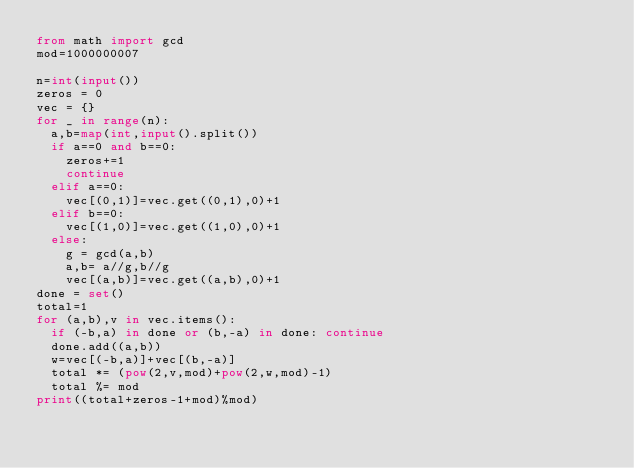<code> <loc_0><loc_0><loc_500><loc_500><_Python_>from math import gcd
mod=1000000007

n=int(input())
zeros = 0
vec = {}
for _ in range(n):
  a,b=map(int,input().split())
  if a==0 and b==0:
    zeros+=1
    continue
  elif a==0:
    vec[(0,1)]=vec.get((0,1),0)+1
  elif b==0:
    vec[(1,0)]=vec.get((1,0),0)+1
  else:
    g = gcd(a,b)
    a,b= a//g,b//g
    vec[(a,b)]=vec.get((a,b),0)+1
done = set()
total=1
for (a,b),v in vec.items():
  if (-b,a) in done or (b,-a) in done: continue
  done.add((a,b))
  w=vec[(-b,a)]+vec[(b,-a)]
  total *= (pow(2,v,mod)+pow(2,w,mod)-1)
  total %= mod
print((total+zeros-1+mod)%mod)
</code> 